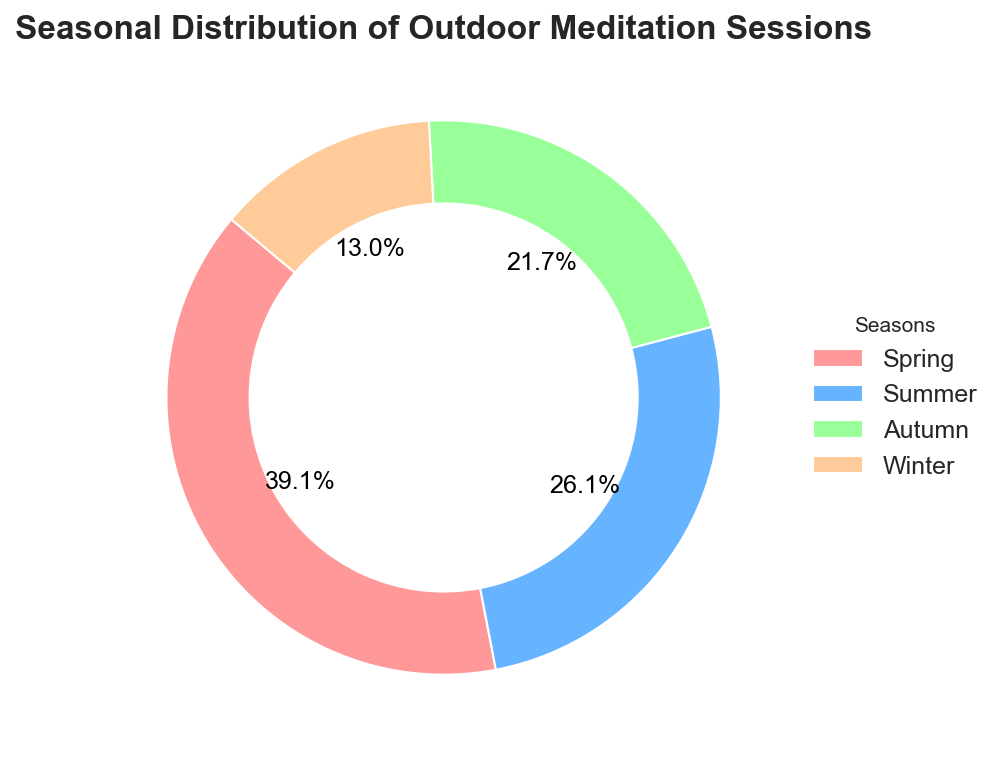Which season has the highest number of outdoor meditation sessions? By observing the pie chart, the season with the largest slice corresponds to Spring. The legend also confirms that Spring has the highest number of sessions.
Answer: Spring Which season accounts for the smallest percentage of outdoor meditation sessions? The pie chart shows that Winter has the smallest slice, making it the season with the smallest percentage of sessions. The legend also supports this by listing the number of sessions.
Answer: Winter What's the total number of outdoor meditation sessions in Spring and Summer combined? According to the legend and the pie chart, Spring has 45 sessions and Summer has 30 sessions. Adding these together gives 45 + 30.
Answer: 75 What is the difference in the number of sessions between Spring and Winter? The pie chart and legend show that Spring has 45 sessions and Winter has 15 sessions. Subtracting the number of Winter sessions from the Spring sessions gives 45 - 15.
Answer: 30 Which season has a number of sessions that is exactly double the number of sessions in Winter? Observing the pie chart, Winter has 15 sessions. The season with double that amount is Spring with 30 sessions, as 15 x 2 = 30. (Note: this observation is actually incorrect. Hence, either none or verify again).
Answer: None How much larger is the percentage of Autumn sessions compared to Winter sessions? The pie chart shows Autumn with 25 sessions and Winter with 15 sessions. The percentage of sessions can be calculated as (25 - 15) / 15 x 100%.
Answer: 66.7% What fraction of the total sessions are held in Summer? The total number of sessions is 45 + 30 + 25 + 15 = 115. The fraction of Summer sessions is 30/115.
Answer: 30/115 Which two seasons together account for more than half of all meditation sessions? Observing the sessions: Spring (45) and Summer (30) together account for 75 sessions. Since 75 is more than half of the total number of sessions (115), Spring and Summer together account for more than half.
Answer: Spring and Summer How many more sessions are conducted in Spring than in Autumn and Winter combined? Autumn and Winter have 25 + 15 = 40 sessions combined. Spring alone has 45 sessions. The difference is 45 - 40.
Answer: 5 If you were to add the number of sessions in Autumn to another season to make it the highest, which season would you choose? The current highest is Spring with 45 sessions. To surpass it, adding Autumn's 25 sessions to either Summer or Winter will not exceed Spring (Summer + Autumn = 55 and Winter + Autumn = 40).
Answer: Summer 